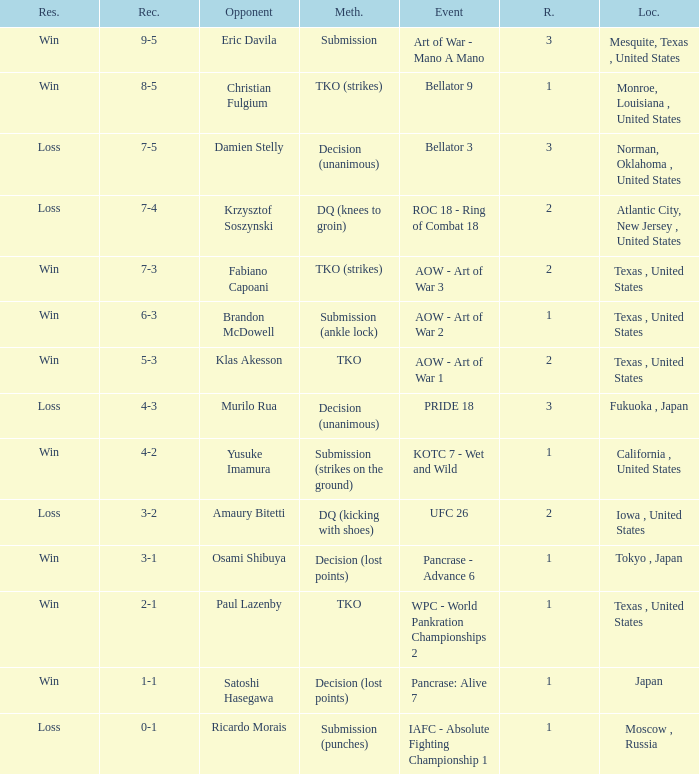What is the average round against opponent Klas Akesson? 2.0. 